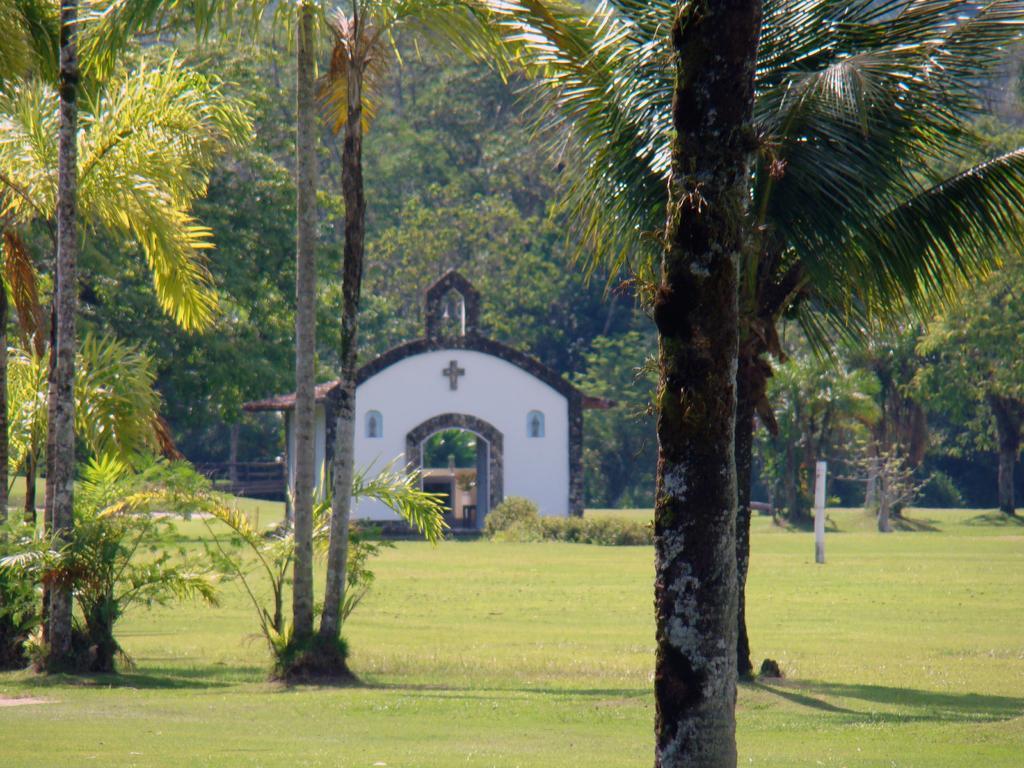Can you describe this image briefly? This picture might be taken outside of the city and it is sunny. In this image, we can see a house, on that house, we can see a cross. On the right side there are some trees, on the left side, we can also see some trees and plants. In the background, we can see a pole, few trees. On the top, we can see a sky, at the bottom there are some plants and grass. 